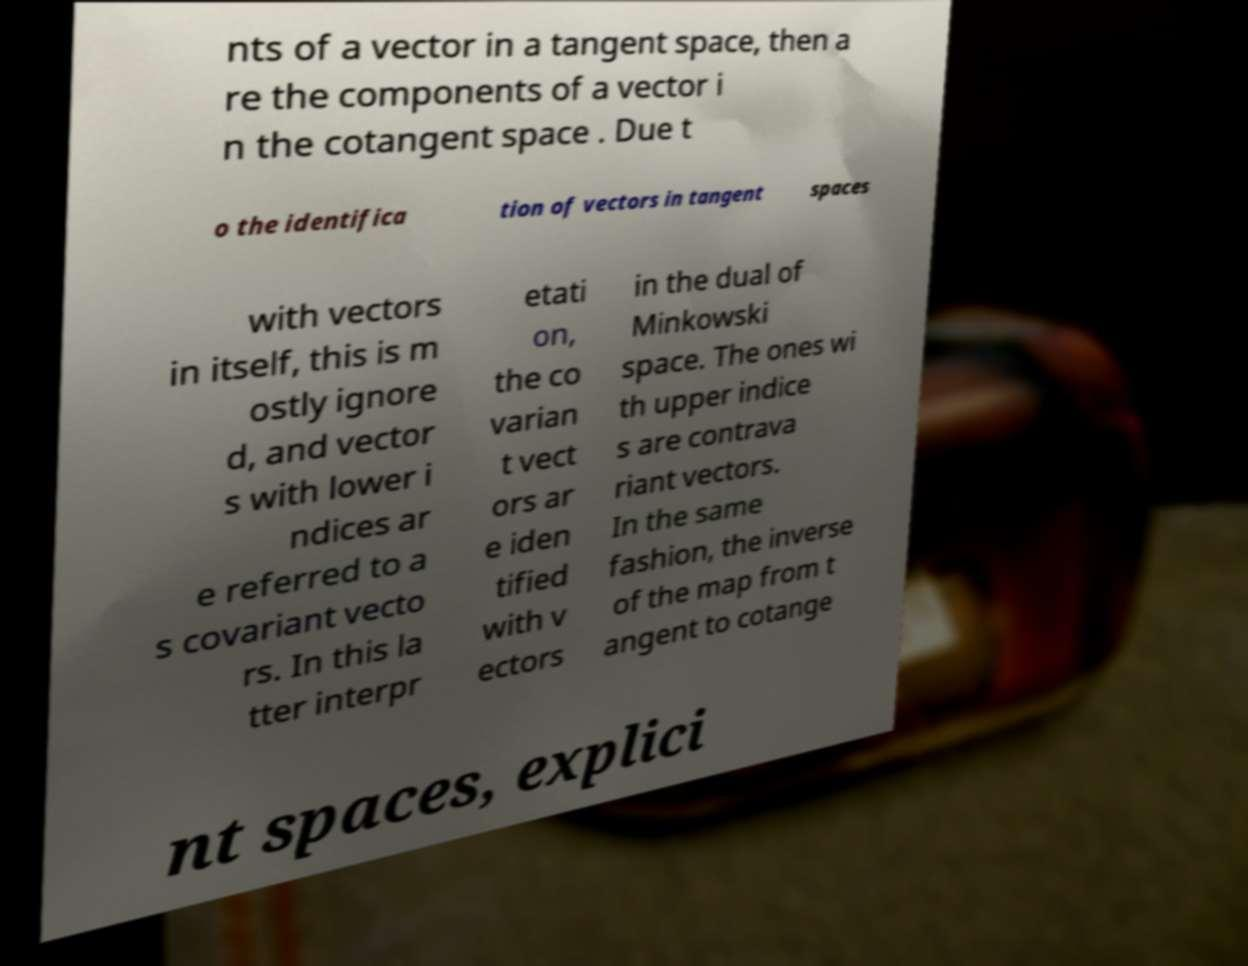Can you accurately transcribe the text from the provided image for me? nts of a vector in a tangent space, then a re the components of a vector i n the cotangent space . Due t o the identifica tion of vectors in tangent spaces with vectors in itself, this is m ostly ignore d, and vector s with lower i ndices ar e referred to a s covariant vecto rs. In this la tter interpr etati on, the co varian t vect ors ar e iden tified with v ectors in the dual of Minkowski space. The ones wi th upper indice s are contrava riant vectors. In the same fashion, the inverse of the map from t angent to cotange nt spaces, explici 